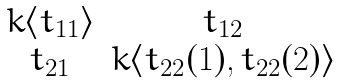Convert formula to latex. <formula><loc_0><loc_0><loc_500><loc_500>\begin{matrix} k \langle t _ { 1 1 } \rangle & t _ { 1 2 } \\ t _ { 2 1 } & k \langle t _ { 2 2 } ( 1 ) , t _ { 2 2 } ( 2 ) \rangle \end{matrix}</formula> 